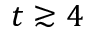Convert formula to latex. <formula><loc_0><loc_0><loc_500><loc_500>t \gtrsim 4</formula> 